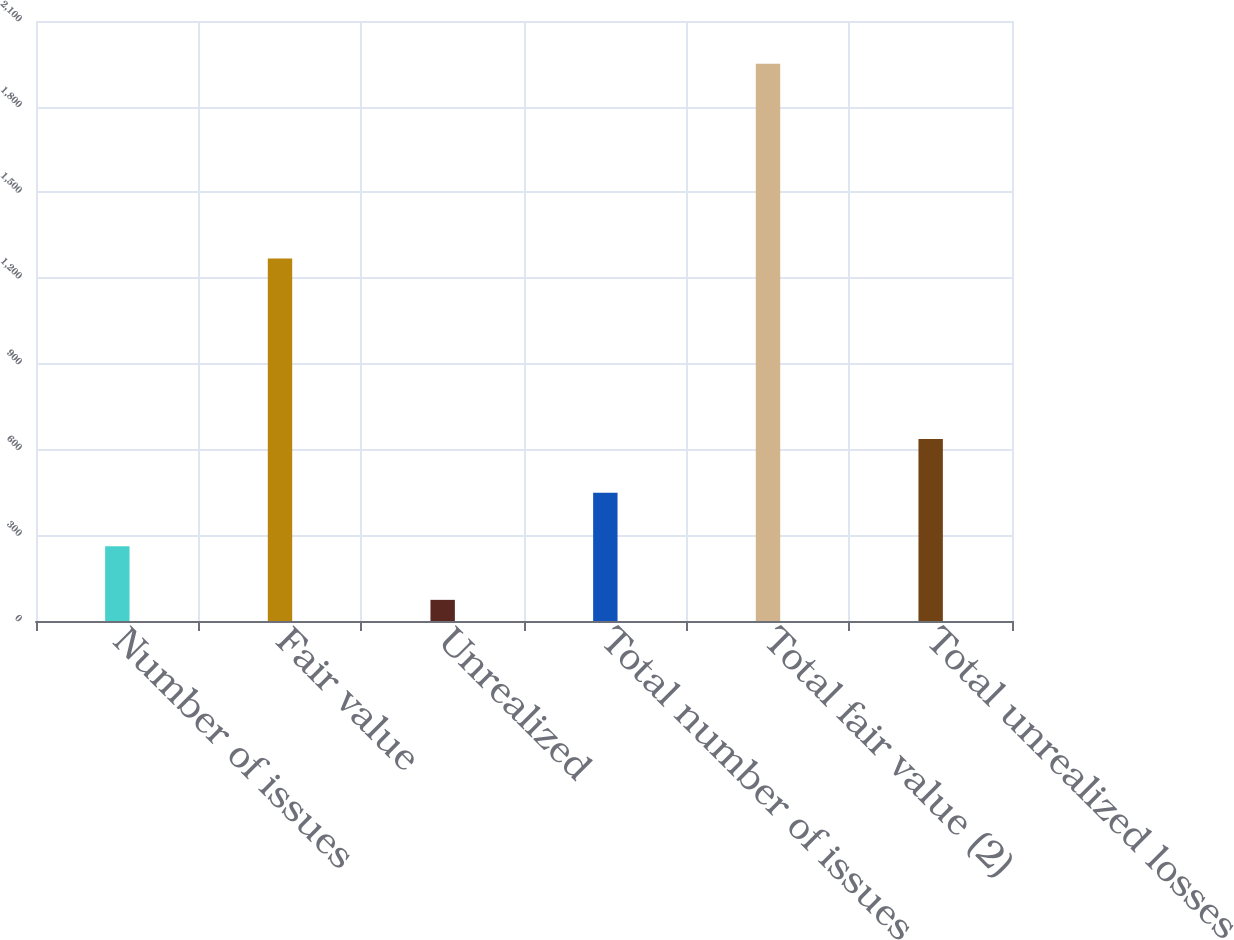Convert chart. <chart><loc_0><loc_0><loc_500><loc_500><bar_chart><fcel>Number of issues<fcel>Fair value<fcel>Unrealized<fcel>Total number of issues<fcel>Total fair value (2)<fcel>Total unrealized losses<nl><fcel>261.6<fcel>1269<fcel>74<fcel>449.2<fcel>1950<fcel>636.8<nl></chart> 